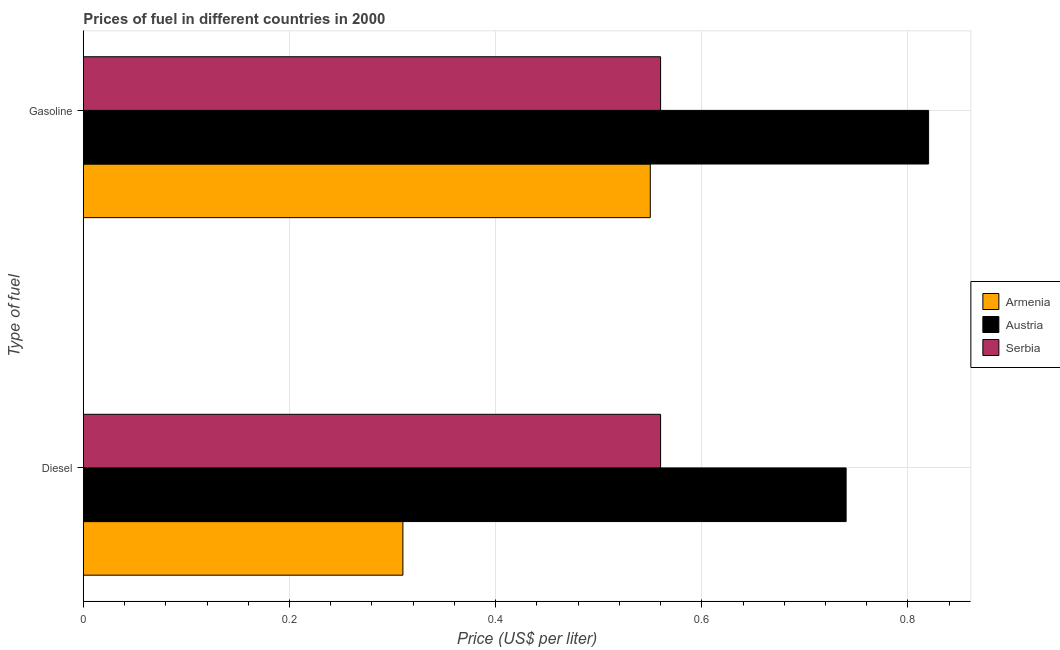How many groups of bars are there?
Keep it short and to the point. 2. Are the number of bars per tick equal to the number of legend labels?
Offer a terse response. Yes. How many bars are there on the 2nd tick from the bottom?
Offer a very short reply. 3. What is the label of the 2nd group of bars from the top?
Keep it short and to the point. Diesel. What is the diesel price in Serbia?
Make the answer very short. 0.56. Across all countries, what is the maximum diesel price?
Offer a terse response. 0.74. Across all countries, what is the minimum gasoline price?
Provide a short and direct response. 0.55. In which country was the gasoline price maximum?
Your answer should be compact. Austria. In which country was the diesel price minimum?
Your response must be concise. Armenia. What is the total gasoline price in the graph?
Ensure brevity in your answer.  1.93. What is the difference between the diesel price in Armenia and that in Austria?
Give a very brief answer. -0.43. What is the difference between the gasoline price in Serbia and the diesel price in Austria?
Your answer should be compact. -0.18. What is the average gasoline price per country?
Make the answer very short. 0.64. What is the difference between the gasoline price and diesel price in Austria?
Offer a very short reply. 0.08. In how many countries, is the gasoline price greater than 0.7600000000000001 US$ per litre?
Keep it short and to the point. 1. What is the ratio of the gasoline price in Armenia to that in Austria?
Keep it short and to the point. 0.67. What does the 3rd bar from the top in Diesel represents?
Offer a very short reply. Armenia. What does the 1st bar from the bottom in Gasoline represents?
Ensure brevity in your answer.  Armenia. How many bars are there?
Offer a terse response. 6. How many countries are there in the graph?
Offer a very short reply. 3. What is the difference between two consecutive major ticks on the X-axis?
Ensure brevity in your answer.  0.2. Are the values on the major ticks of X-axis written in scientific E-notation?
Offer a terse response. No. Does the graph contain grids?
Make the answer very short. Yes. Where does the legend appear in the graph?
Offer a very short reply. Center right. How many legend labels are there?
Your response must be concise. 3. What is the title of the graph?
Offer a very short reply. Prices of fuel in different countries in 2000. What is the label or title of the X-axis?
Offer a terse response. Price (US$ per liter). What is the label or title of the Y-axis?
Offer a very short reply. Type of fuel. What is the Price (US$ per liter) of Armenia in Diesel?
Provide a succinct answer. 0.31. What is the Price (US$ per liter) of Austria in Diesel?
Keep it short and to the point. 0.74. What is the Price (US$ per liter) of Serbia in Diesel?
Give a very brief answer. 0.56. What is the Price (US$ per liter) of Armenia in Gasoline?
Make the answer very short. 0.55. What is the Price (US$ per liter) of Austria in Gasoline?
Offer a terse response. 0.82. What is the Price (US$ per liter) of Serbia in Gasoline?
Provide a succinct answer. 0.56. Across all Type of fuel, what is the maximum Price (US$ per liter) in Armenia?
Keep it short and to the point. 0.55. Across all Type of fuel, what is the maximum Price (US$ per liter) in Austria?
Your response must be concise. 0.82. Across all Type of fuel, what is the maximum Price (US$ per liter) in Serbia?
Make the answer very short. 0.56. Across all Type of fuel, what is the minimum Price (US$ per liter) of Armenia?
Ensure brevity in your answer.  0.31. Across all Type of fuel, what is the minimum Price (US$ per liter) of Austria?
Your answer should be very brief. 0.74. Across all Type of fuel, what is the minimum Price (US$ per liter) of Serbia?
Give a very brief answer. 0.56. What is the total Price (US$ per liter) in Armenia in the graph?
Provide a short and direct response. 0.86. What is the total Price (US$ per liter) in Austria in the graph?
Keep it short and to the point. 1.56. What is the total Price (US$ per liter) of Serbia in the graph?
Your answer should be compact. 1.12. What is the difference between the Price (US$ per liter) in Armenia in Diesel and that in Gasoline?
Your answer should be very brief. -0.24. What is the difference between the Price (US$ per liter) of Austria in Diesel and that in Gasoline?
Your answer should be compact. -0.08. What is the difference between the Price (US$ per liter) of Armenia in Diesel and the Price (US$ per liter) of Austria in Gasoline?
Ensure brevity in your answer.  -0.51. What is the difference between the Price (US$ per liter) in Austria in Diesel and the Price (US$ per liter) in Serbia in Gasoline?
Keep it short and to the point. 0.18. What is the average Price (US$ per liter) in Armenia per Type of fuel?
Give a very brief answer. 0.43. What is the average Price (US$ per liter) in Austria per Type of fuel?
Your response must be concise. 0.78. What is the average Price (US$ per liter) of Serbia per Type of fuel?
Make the answer very short. 0.56. What is the difference between the Price (US$ per liter) in Armenia and Price (US$ per liter) in Austria in Diesel?
Offer a terse response. -0.43. What is the difference between the Price (US$ per liter) in Austria and Price (US$ per liter) in Serbia in Diesel?
Provide a succinct answer. 0.18. What is the difference between the Price (US$ per liter) of Armenia and Price (US$ per liter) of Austria in Gasoline?
Your answer should be very brief. -0.27. What is the difference between the Price (US$ per liter) of Armenia and Price (US$ per liter) of Serbia in Gasoline?
Make the answer very short. -0.01. What is the difference between the Price (US$ per liter) in Austria and Price (US$ per liter) in Serbia in Gasoline?
Your answer should be very brief. 0.26. What is the ratio of the Price (US$ per liter) of Armenia in Diesel to that in Gasoline?
Give a very brief answer. 0.56. What is the ratio of the Price (US$ per liter) of Austria in Diesel to that in Gasoline?
Your answer should be compact. 0.9. What is the ratio of the Price (US$ per liter) in Serbia in Diesel to that in Gasoline?
Your response must be concise. 1. What is the difference between the highest and the second highest Price (US$ per liter) of Armenia?
Provide a succinct answer. 0.24. What is the difference between the highest and the second highest Price (US$ per liter) in Austria?
Provide a short and direct response. 0.08. What is the difference between the highest and the lowest Price (US$ per liter) in Armenia?
Offer a terse response. 0.24. 